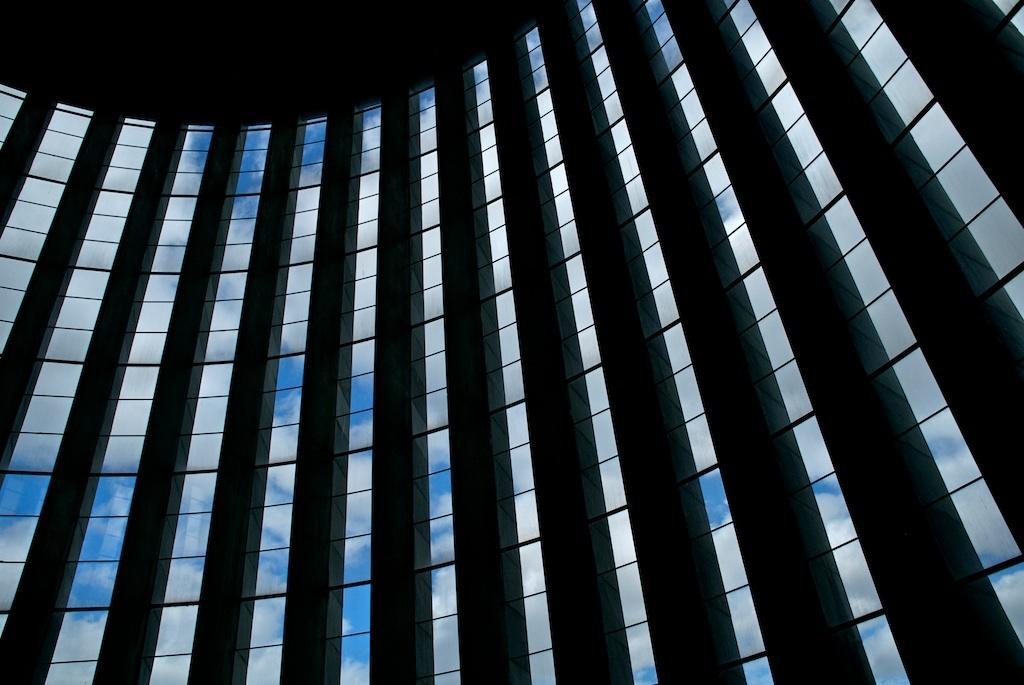Can you describe this image briefly? In this image there are pillars and glass windows and through the windows we could see sky, and there is a dark top. 